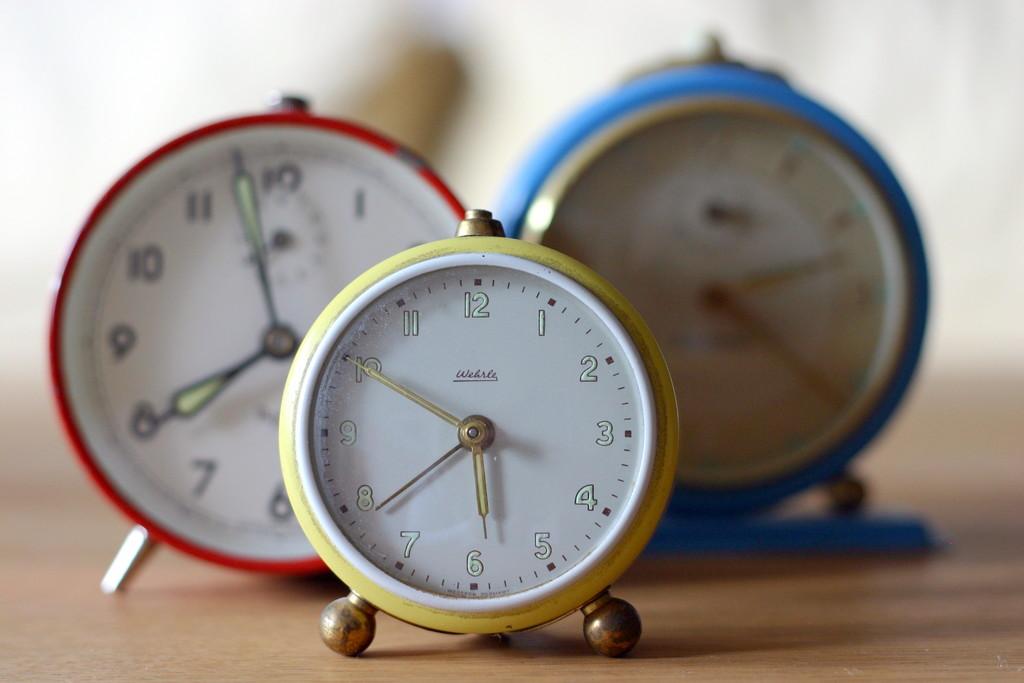What time is it on the nearest clock?
Offer a very short reply. 5:50. What time is on the middle clock?
Keep it short and to the point. 5:50. 